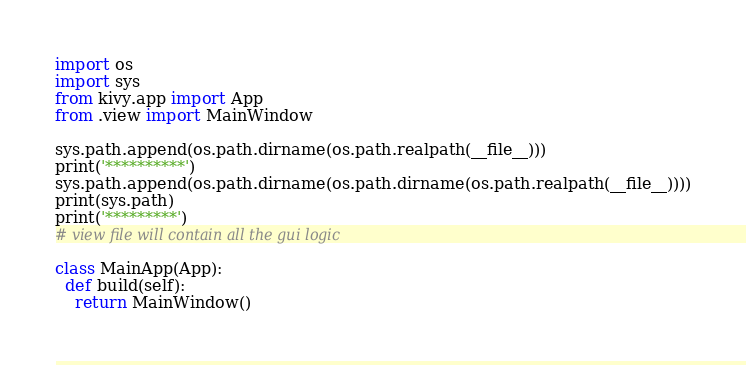<code> <loc_0><loc_0><loc_500><loc_500><_Python_>import os
import sys
from kivy.app import App
from .view import MainWindow

sys.path.append(os.path.dirname(os.path.realpath(__file__)))
print('**********')
sys.path.append(os.path.dirname(os.path.dirname(os.path.realpath(__file__))))
print(sys.path)
print('*********')
# view file will contain all the gui logic

class MainApp(App):
  def build(self):
    return MainWindow()
</code> 